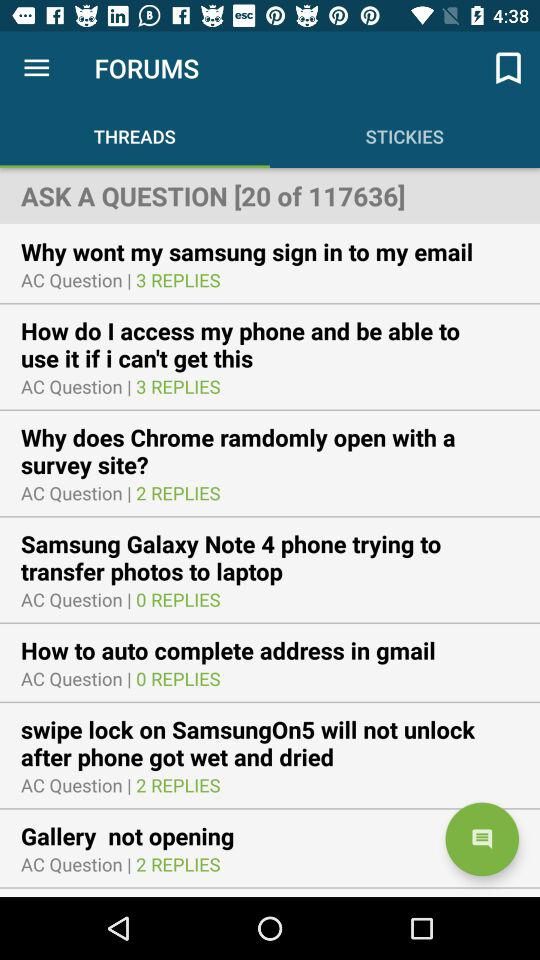How many questions have no replies?
Answer the question using a single word or phrase. 2 